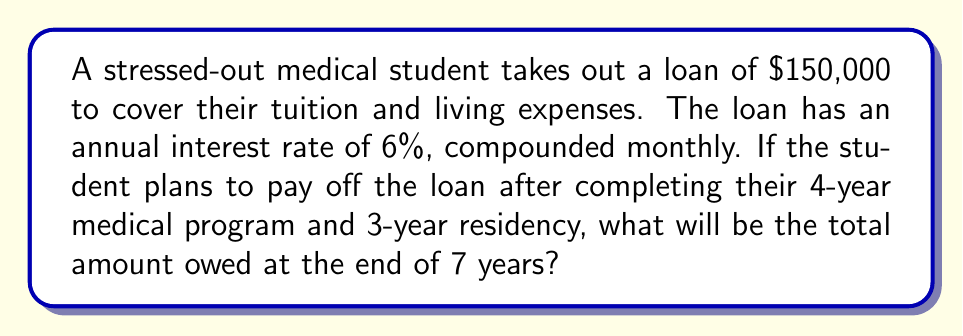Can you answer this question? To solve this problem, we'll use the compound interest formula:

$$A = P(1 + \frac{r}{n})^{nt}$$

Where:
$A$ = final amount
$P$ = principal (initial loan amount)
$r$ = annual interest rate (as a decimal)
$n$ = number of times interest is compounded per year
$t$ = time in years

Given:
$P = 150,000$
$r = 0.06$ (6% as a decimal)
$n = 12$ (compounded monthly)
$t = 7$ (4 years of medical school + 3 years of residency)

Let's substitute these values into the formula:

$$A = 150,000(1 + \frac{0.06}{12})^{12 \cdot 7}$$

$$A = 150,000(1 + 0.005)^{84}$$

$$A = 150,000(1.005)^{84}$$

Using a calculator or computer to evaluate this expression:

$$A = 150,000 \cdot 1.5194697...$$

$$A = 227,920.46$$

Therefore, the total amount owed after 7 years will be $227,920.46.
Answer: $227,920.46 